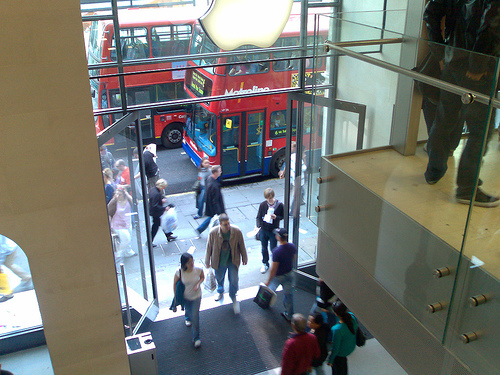<image>
Is there a bus on the sidewalk? No. The bus is not positioned on the sidewalk. They may be near each other, but the bus is not supported by or resting on top of the sidewalk. 